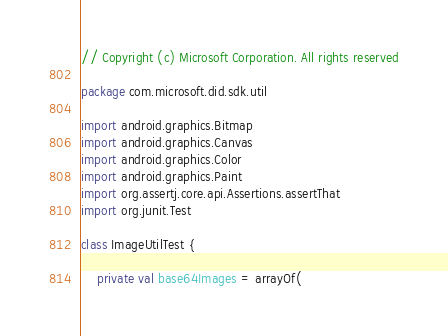<code> <loc_0><loc_0><loc_500><loc_500><_Kotlin_>// Copyright (c) Microsoft Corporation. All rights reserved

package com.microsoft.did.sdk.util

import android.graphics.Bitmap
import android.graphics.Canvas
import android.graphics.Color
import android.graphics.Paint
import org.assertj.core.api.Assertions.assertThat
import org.junit.Test

class ImageUtilTest {

    private val base64Images = arrayOf(</code> 